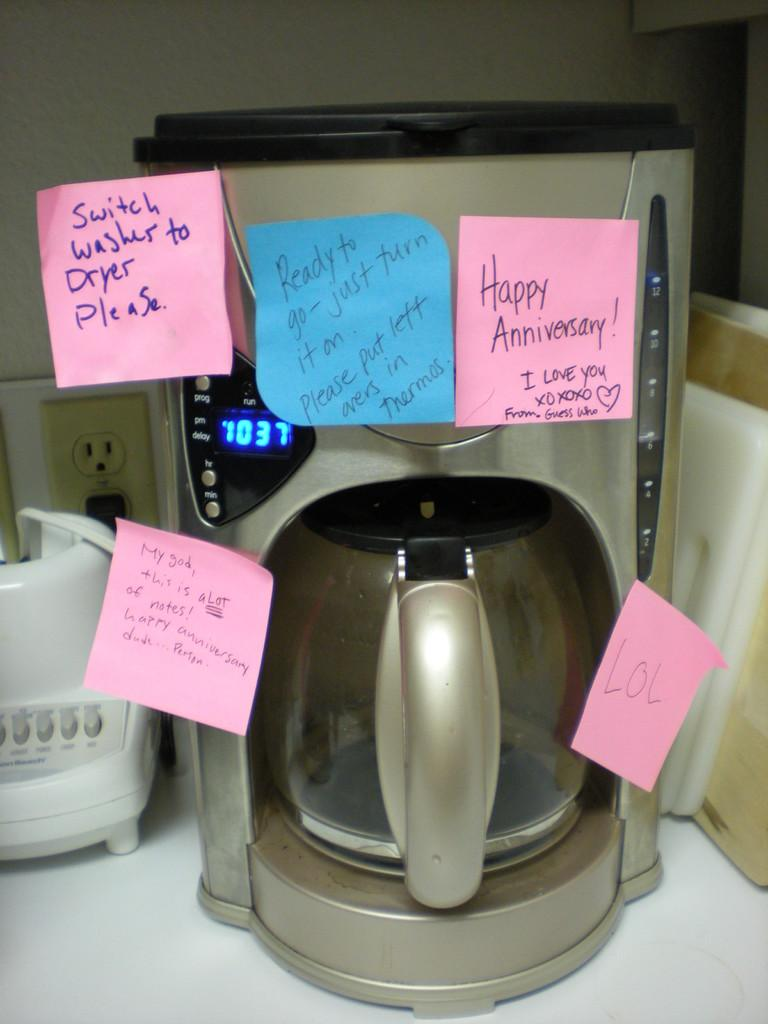<image>
Render a clear and concise summary of the photo. A pink sticky note that says "happy Anniversary! hangs from a coffee maker 